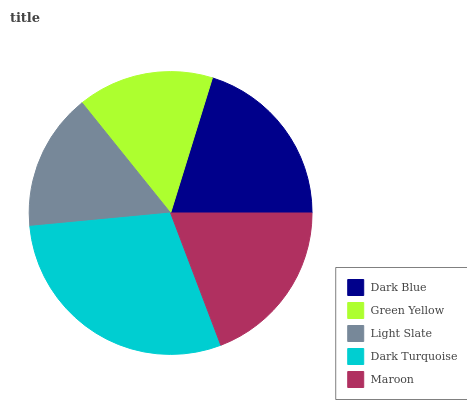Is Green Yellow the minimum?
Answer yes or no. Yes. Is Dark Turquoise the maximum?
Answer yes or no. Yes. Is Light Slate the minimum?
Answer yes or no. No. Is Light Slate the maximum?
Answer yes or no. No. Is Light Slate greater than Green Yellow?
Answer yes or no. Yes. Is Green Yellow less than Light Slate?
Answer yes or no. Yes. Is Green Yellow greater than Light Slate?
Answer yes or no. No. Is Light Slate less than Green Yellow?
Answer yes or no. No. Is Maroon the high median?
Answer yes or no. Yes. Is Maroon the low median?
Answer yes or no. Yes. Is Light Slate the high median?
Answer yes or no. No. Is Dark Turquoise the low median?
Answer yes or no. No. 